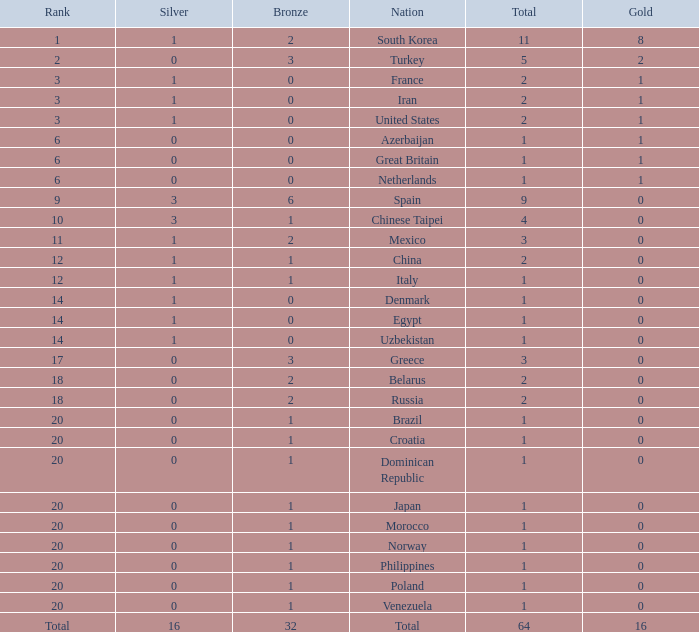What is the lowest number of gold medals the nation with less than 0 silver medals has? None. 